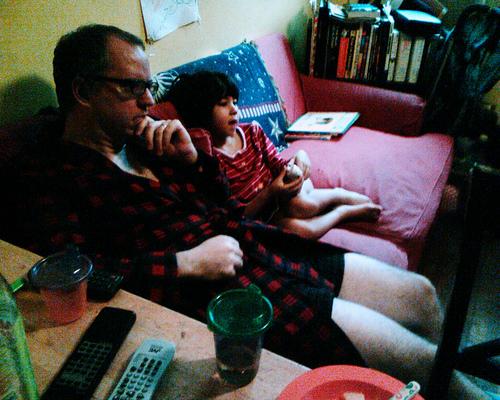How many children are there?
Short answer required. 1. Are these people dressed formally?
Quick response, please. No. What is the girl holding?
Quick response, please. Toy. Where are the remote controllers?
Be succinct. On table. 